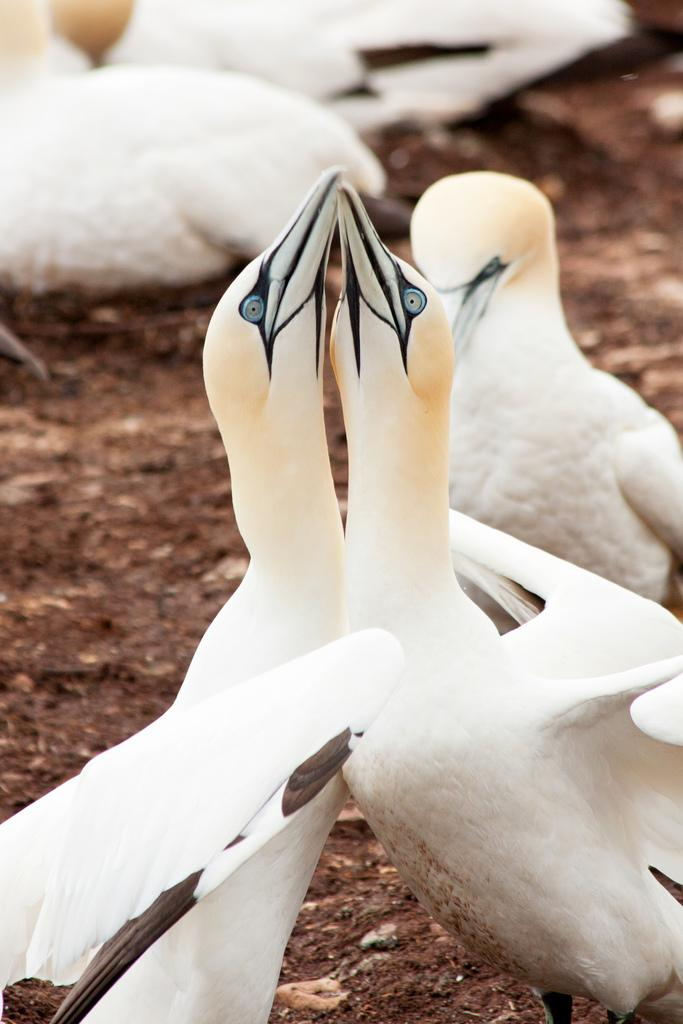What type of animals can be seen on the surface in the image? There are birds on the surface in the image. Can you describe the birds' location or position on the surface? The provided facts do not specify the birds' location or position on the surface. What might the birds be doing on the surface? The birds might be resting, feeding, or socializing on the surface. What type of instrument is the bird playing in the image? There is no instrument present in the image, and the birds are not playing any instruments. 